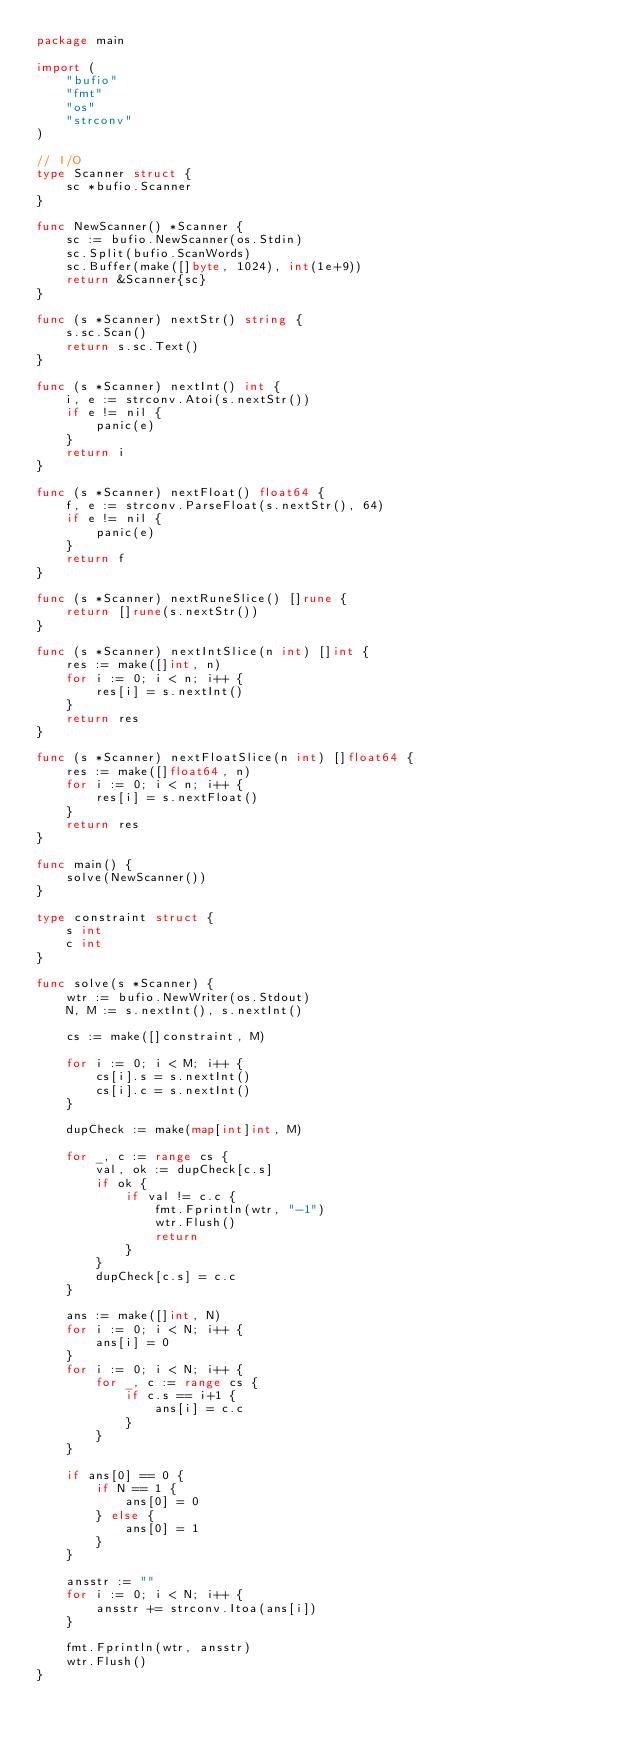<code> <loc_0><loc_0><loc_500><loc_500><_Go_>package main

import (
	"bufio"
	"fmt"
	"os"
	"strconv"
)

// I/O
type Scanner struct {
	sc *bufio.Scanner
}

func NewScanner() *Scanner {
	sc := bufio.NewScanner(os.Stdin)
	sc.Split(bufio.ScanWords)
	sc.Buffer(make([]byte, 1024), int(1e+9))
	return &Scanner{sc}
}

func (s *Scanner) nextStr() string {
	s.sc.Scan()
	return s.sc.Text()
}

func (s *Scanner) nextInt() int {
	i, e := strconv.Atoi(s.nextStr())
	if e != nil {
		panic(e)
	}
	return i
}

func (s *Scanner) nextFloat() float64 {
	f, e := strconv.ParseFloat(s.nextStr(), 64)
	if e != nil {
		panic(e)
	}
	return f
}

func (s *Scanner) nextRuneSlice() []rune {
	return []rune(s.nextStr())
}

func (s *Scanner) nextIntSlice(n int) []int {
	res := make([]int, n)
	for i := 0; i < n; i++ {
		res[i] = s.nextInt()
	}
	return res
}

func (s *Scanner) nextFloatSlice(n int) []float64 {
	res := make([]float64, n)
	for i := 0; i < n; i++ {
		res[i] = s.nextFloat()
	}
	return res
}

func main() {
	solve(NewScanner())
}

type constraint struct {
	s int
	c int
}

func solve(s *Scanner) {
	wtr := bufio.NewWriter(os.Stdout)
	N, M := s.nextInt(), s.nextInt()

	cs := make([]constraint, M)

	for i := 0; i < M; i++ {
		cs[i].s = s.nextInt()
		cs[i].c = s.nextInt()
	}

	dupCheck := make(map[int]int, M)

	for _, c := range cs {
		val, ok := dupCheck[c.s]
		if ok {
			if val != c.c {
				fmt.Fprintln(wtr, "-1")
				wtr.Flush()
				return
			}
		}
		dupCheck[c.s] = c.c
	}

	ans := make([]int, N)
	for i := 0; i < N; i++ {
		ans[i] = 0
	}
	for i := 0; i < N; i++ {
		for _, c := range cs {
			if c.s == i+1 {
				ans[i] = c.c
			}
		}
	}

	if ans[0] == 0 {
		if N == 1 {
			ans[0] = 0
		} else {
			ans[0] = 1
		}
	}

	ansstr := ""
	for i := 0; i < N; i++ {
		ansstr += strconv.Itoa(ans[i])
	}

	fmt.Fprintln(wtr, ansstr)
	wtr.Flush()
}
</code> 